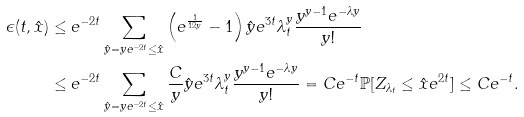<formula> <loc_0><loc_0><loc_500><loc_500>\epsilon ( t , \hat { x } ) & \leq e ^ { - 2 t } \sum _ { \hat { y } = y e ^ { - 2 t } \leq \hat { x } } \left ( e ^ { \frac { 1 } { 1 2 y } } - 1 \right ) \hat { y } e ^ { 3 t } \lambda _ { t } ^ { y } \frac { y ^ { y - 1 } e ^ { - \lambda y } } { y ! } \\ & \leq e ^ { - 2 t } \sum _ { \hat { y } = y e ^ { - 2 t } \leq \hat { x } } \frac { C } { y } \hat { y } e ^ { 3 t } \lambda _ { t } ^ { y } \frac { y ^ { y - 1 } e ^ { - \lambda y } } { y ! } = C e ^ { - t } \mathbb { P } [ Z _ { \lambda _ { t } } \leq \hat { x } e ^ { 2 t } ] \leq C e ^ { - t } .</formula> 